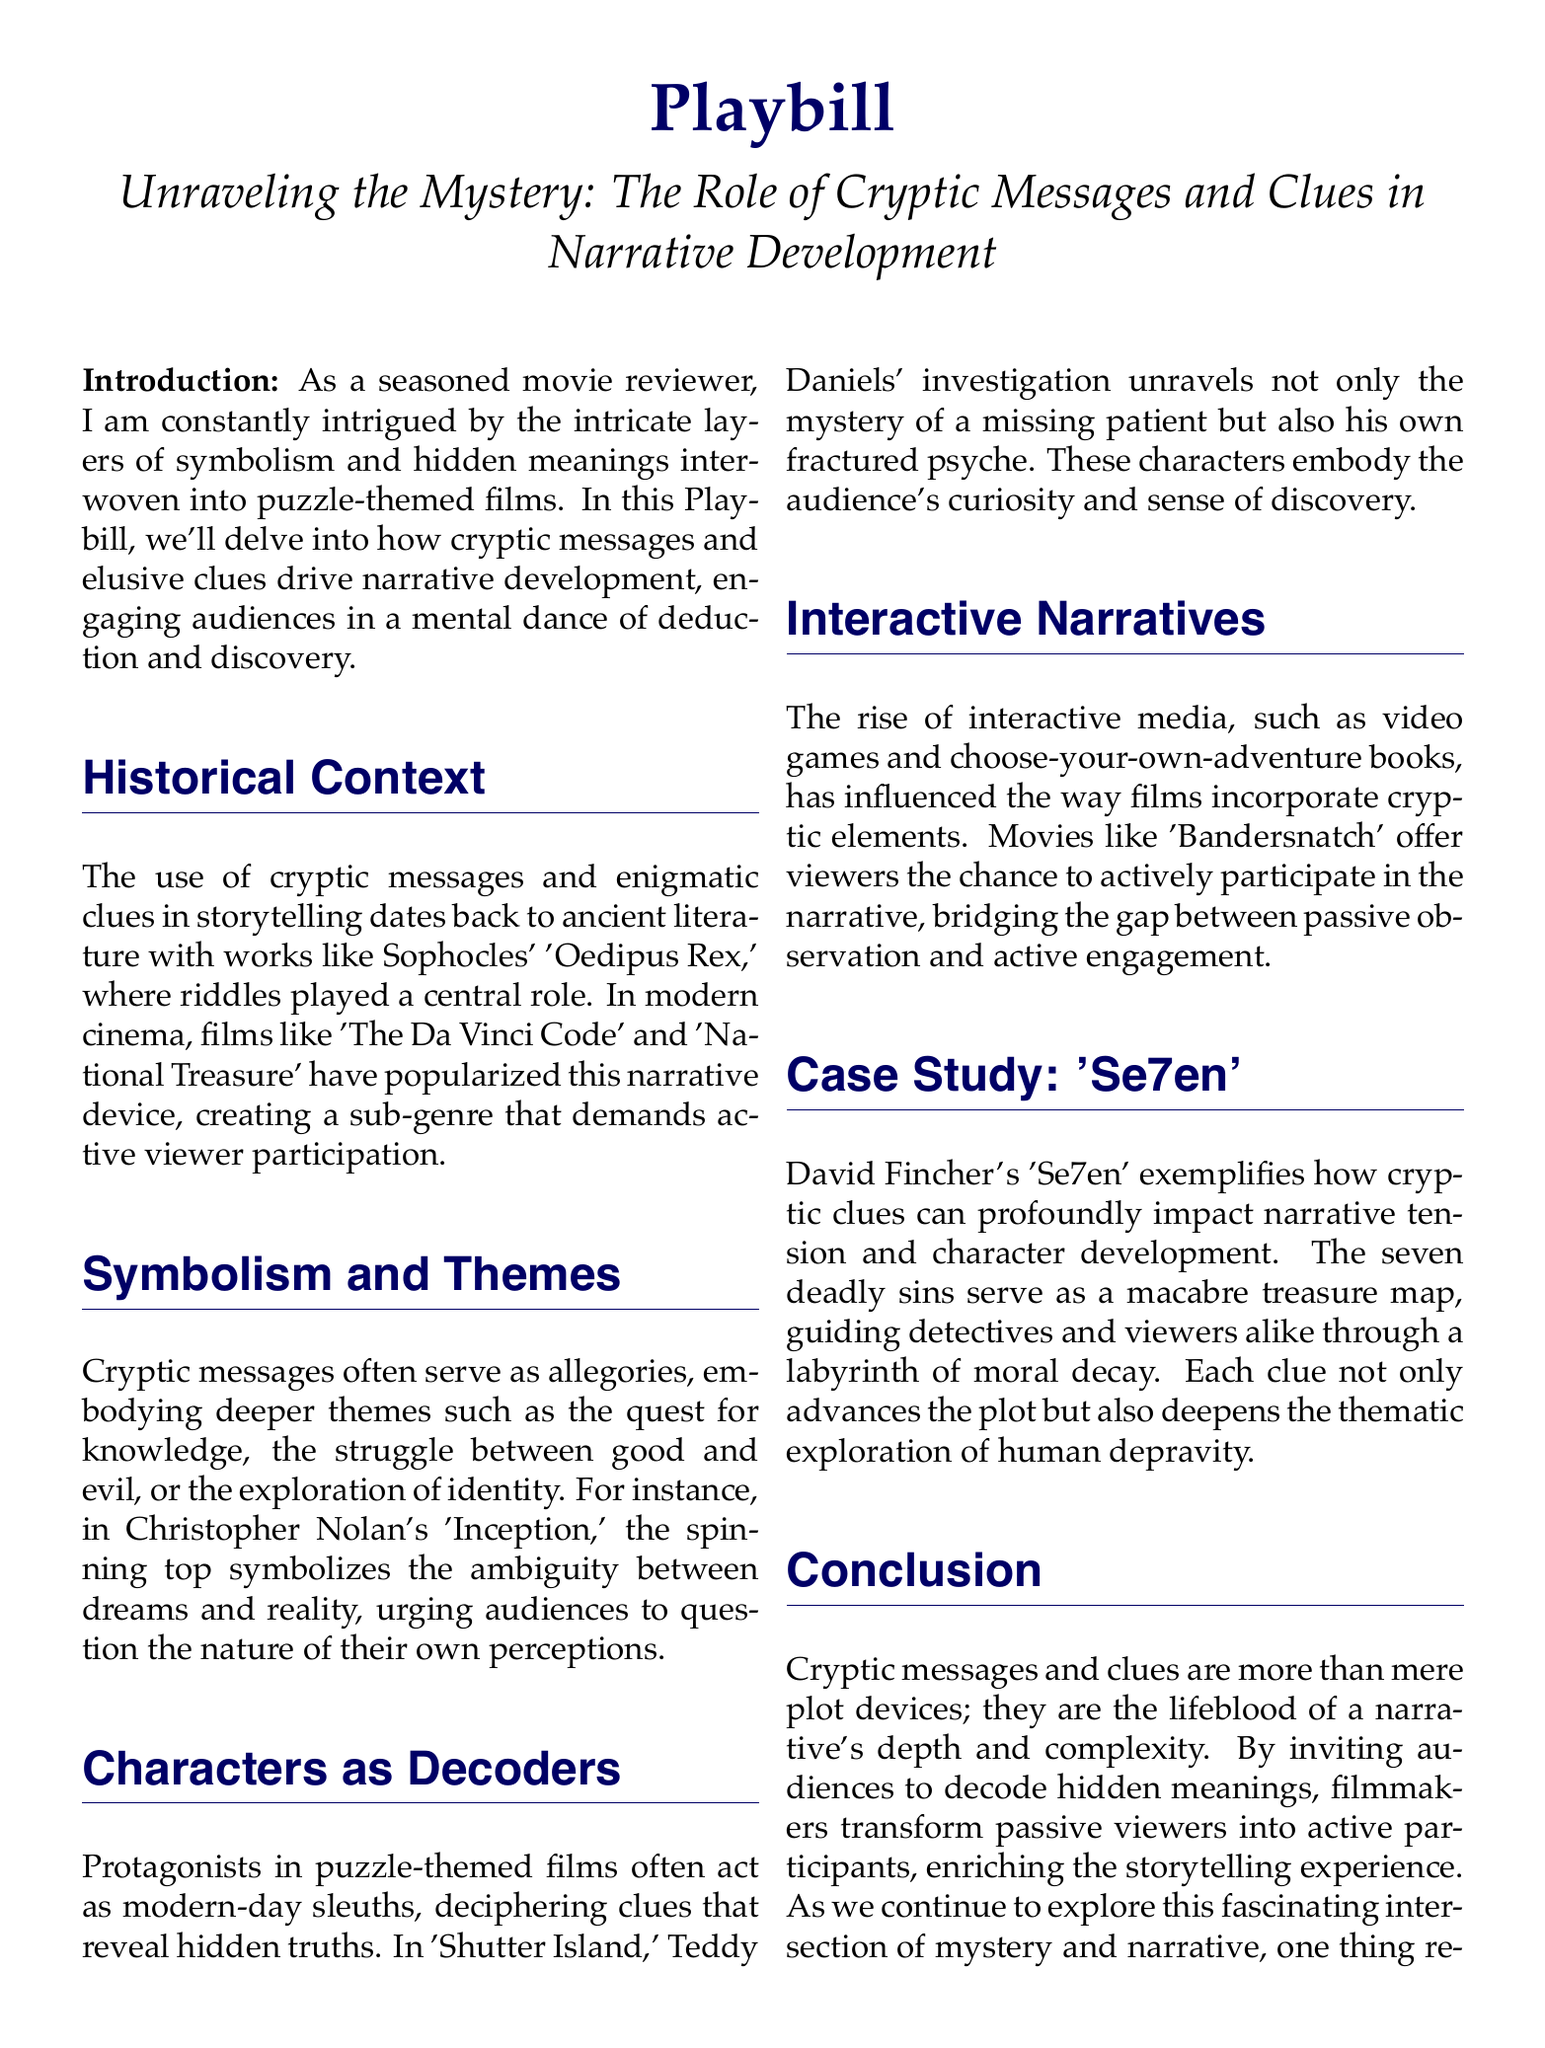What is the title of the Playbill? The title of the Playbill is introduced at the top of the document, stating the theme of the discussion.
Answer: Unraveling the Mystery: The Role of Cryptic Messages and Clues in Narrative Development Who is the author of the document? The author is mentioned at the end of the Playbill, indicating their identity as a seasoned movie reviewer.
Answer: Esteemed Movie Reviewer - [Your Name] Which film is analyzed in the case study section? The case study section specifically focuses on one film as an example of how cryptic clues enhance narrative tension.
Answer: Se7en What thematic element do cryptic messages often embody according to the document? The document lists several deeper themes that cryptic messages can symbolize, each exploring different aspects of human experience.
Answer: Quest for knowledge What does the spinning top symbolize in 'Inception'? The document explains the significance of a specific object in 'Inception' as a representation of the film's thematic exploration.
Answer: Ambiguity between dreams and reality What type of media influenced puzzle-themed films according to the introduction? The introductory section mentions a specific type of interactive media that has an impact on how cryptic elements are incorporated into films.
Answer: Video games What main themes does 'Se7en' explore through its narrative devices? The Playbill describes the thematic exploration of a film exemplified in the case study, reflecting on human nature.
Answer: Moral decay In which ancient work were riddles central to the story? The historical context section refers to a famous ancient playwright's work, showcasing the longstanding tradition of cryptic storytelling.
Answer: Oedipus Rex Which film exemplifies the active viewer participation technique? The document provides an example of a film that allows the audience to actively engage with the narrative, highlighting its innovative storytelling method.
Answer: Bandersnatch 